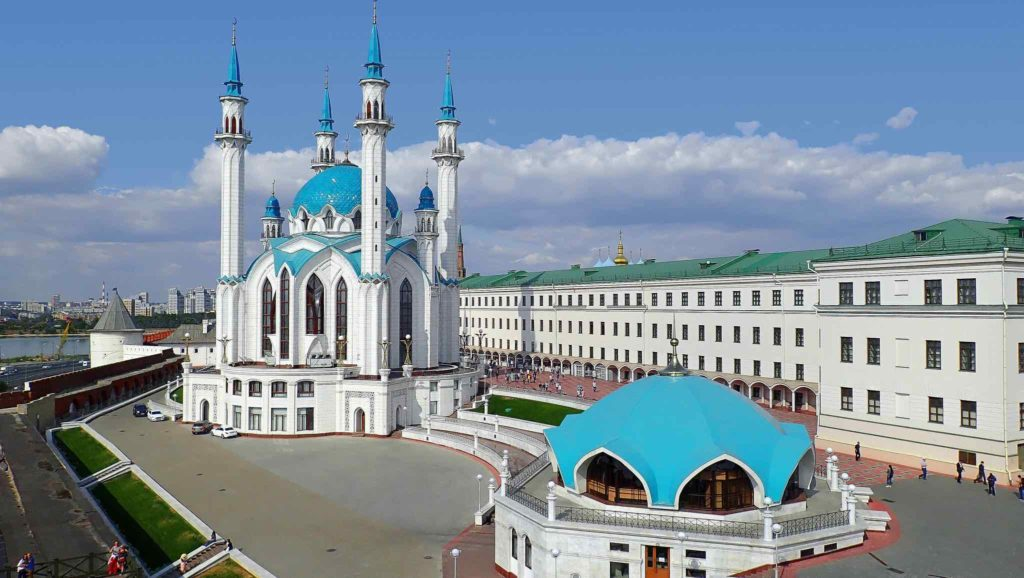If you were to write a poem inspired by this scene, how would it go? Within the Kremlin's hallowed walls,
Where history and beauty blend and call,
The Kul Sharif Mosque stands tall and bright,
A beacon in the day and night.

Four minarets touch the azure sky,
As if in prayer, they reach up high.
Its domes of blue, like heavens' hue,
Reflect a heritage, strong and true.

Beside, the Palace, green-roofed and grand,
A seat of power in this proud land.
Enclosed by walls, old and red,
With stories of the past, they thread.

On lawns so green and pathways wide,
Tales of old warriors and kings abide.
Beneath the sky, both fair and bright,
The Kremlin stands in timeless light. 